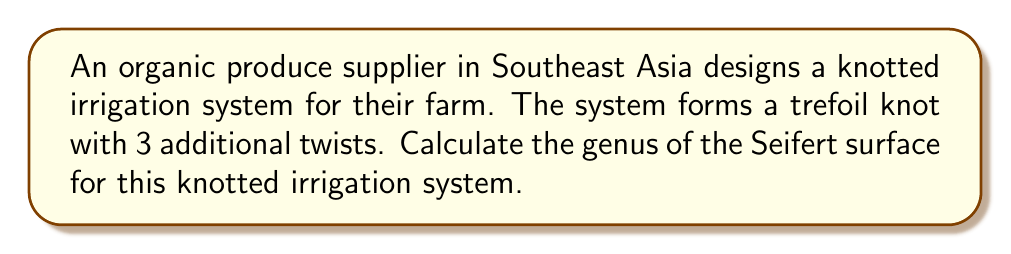Can you answer this question? To calculate the genus of the Seifert surface for the knotted irrigation system, we'll follow these steps:

1. Identify the knot: The system forms a trefoil knot with 3 additional twists.

2. Calculate the crossing number (c):
   - Trefoil knot has 3 crossings
   - Each additional twist adds 2 crossings
   - Total crossings: $c = 3 + (3 \times 2) = 9$

3. Determine the number of Seifert circles (s):
   - For alternating knots (which includes the trefoil), the number of Seifert circles is:
     $s = c - n + 2$, where n is the number of components (1 for a knot)
   - $s = 9 - 1 + 2 = 10$

4. Use the formula for the genus (g) of a Seifert surface:
   $$g = \frac{1}{2}(c - s + 1)$$

5. Substitute the values:
   $$g = \frac{1}{2}(9 - 10 + 1) = \frac{1}{2}(0) = 0$$

Therefore, the genus of the Seifert surface for this knotted irrigation system is 0.
Answer: 0 